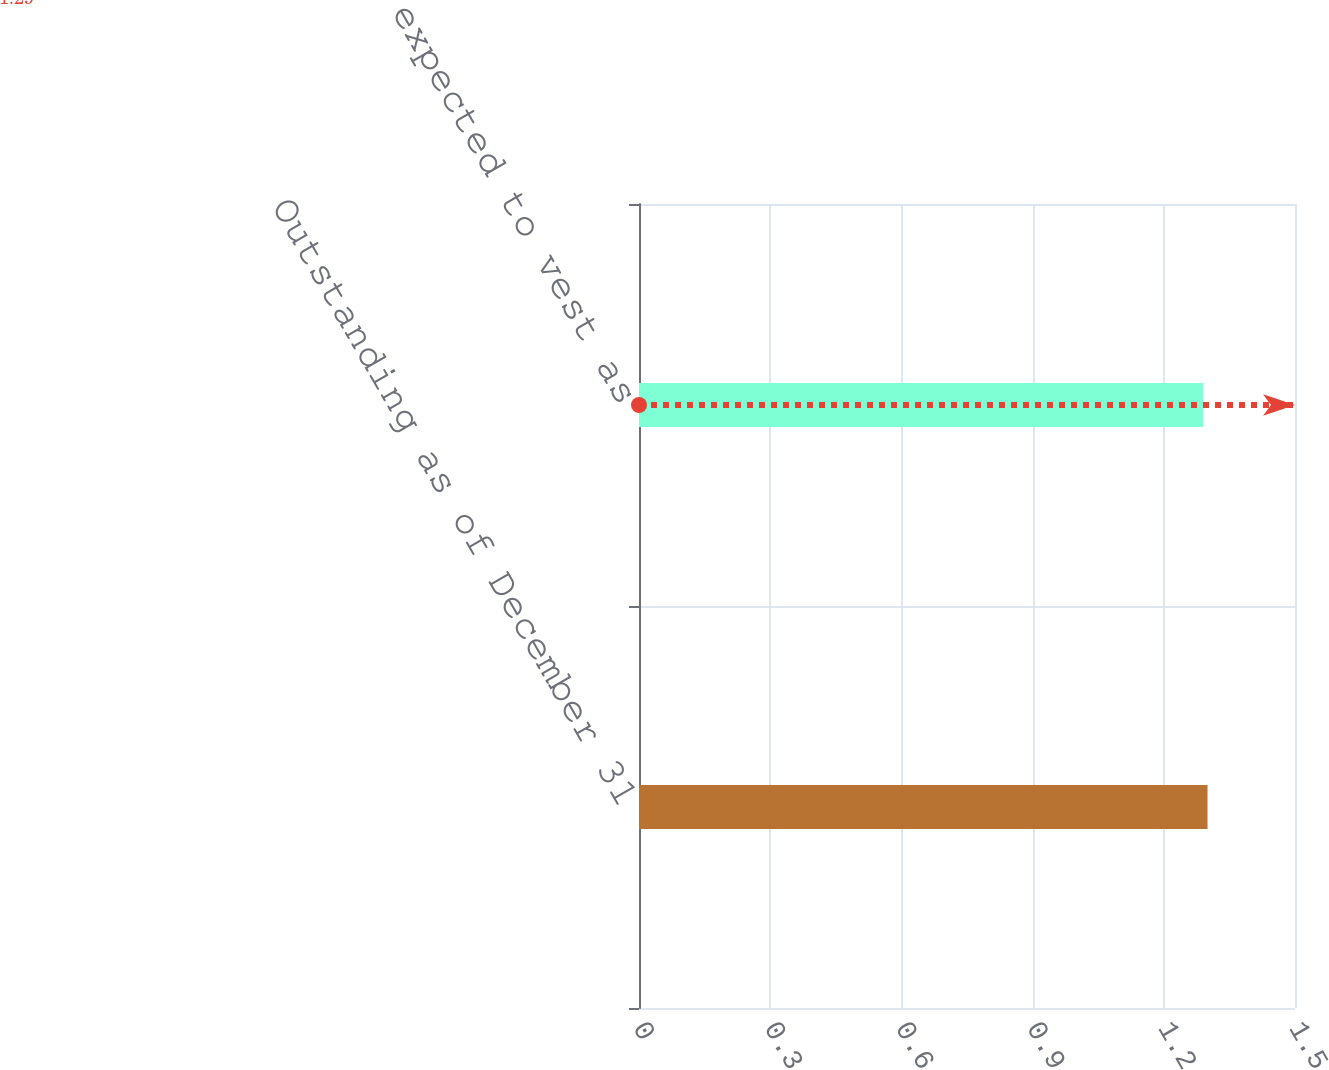Convert chart to OTSL. <chart><loc_0><loc_0><loc_500><loc_500><bar_chart><fcel>Outstanding as of December 31<fcel>Vested and expected to vest as<nl><fcel>1.3<fcel>1.29<nl></chart> 